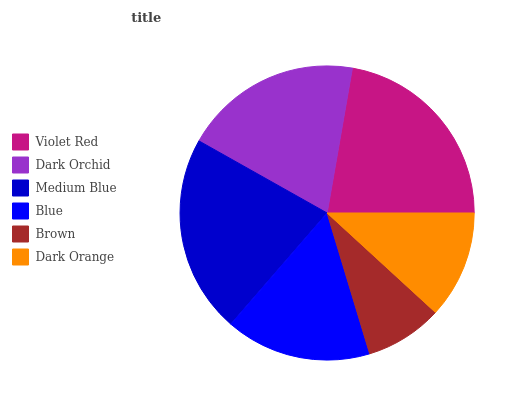Is Brown the minimum?
Answer yes or no. Yes. Is Violet Red the maximum?
Answer yes or no. Yes. Is Dark Orchid the minimum?
Answer yes or no. No. Is Dark Orchid the maximum?
Answer yes or no. No. Is Violet Red greater than Dark Orchid?
Answer yes or no. Yes. Is Dark Orchid less than Violet Red?
Answer yes or no. Yes. Is Dark Orchid greater than Violet Red?
Answer yes or no. No. Is Violet Red less than Dark Orchid?
Answer yes or no. No. Is Dark Orchid the high median?
Answer yes or no. Yes. Is Blue the low median?
Answer yes or no. Yes. Is Blue the high median?
Answer yes or no. No. Is Dark Orange the low median?
Answer yes or no. No. 